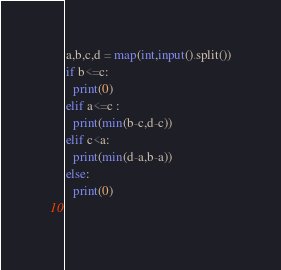<code> <loc_0><loc_0><loc_500><loc_500><_Python_>a,b,c,d = map(int,input().split())
if b<=c:
  print(0)
elif a<=c :
  print(min(b-c,d-c))
elif c<a:
  print(min(d-a,b-a))
else:
  print(0)
  </code> 